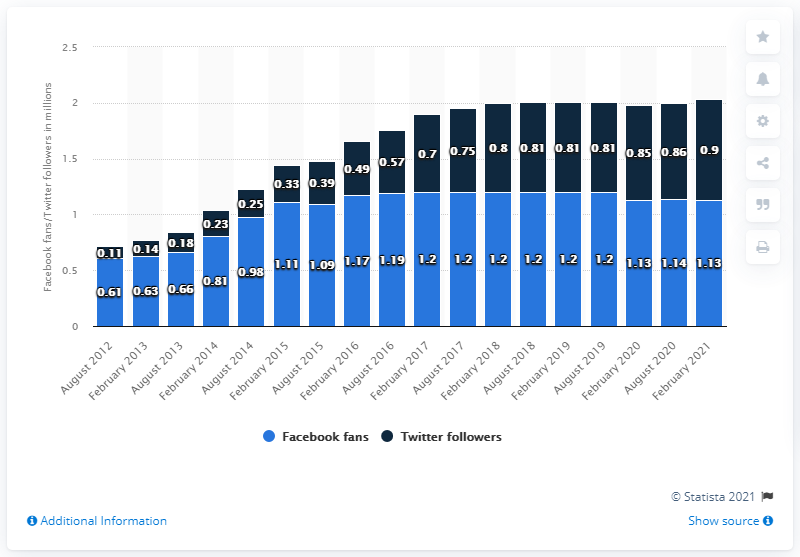Outline some significant characteristics in this image. In February 2021, the Cincinnati Bengals football team had 1.13 million Facebook fans. The Cincinnati Bengals had their Facebook page last updated in August 2012. On February 2021, the Facebook page of the Cincinnati Bengals reached 1.13 million followers. 